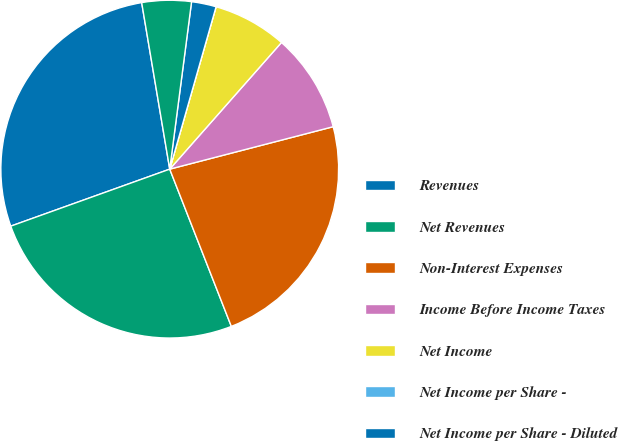Convert chart to OTSL. <chart><loc_0><loc_0><loc_500><loc_500><pie_chart><fcel>Revenues<fcel>Net Revenues<fcel>Non-Interest Expenses<fcel>Income Before Income Taxes<fcel>Net Income<fcel>Net Income per Share -<fcel>Net Income per Share - Diluted<fcel>Dividends Declared per Share<nl><fcel>27.82%<fcel>25.46%<fcel>23.1%<fcel>9.45%<fcel>7.08%<fcel>0.0%<fcel>2.36%<fcel>4.72%<nl></chart> 